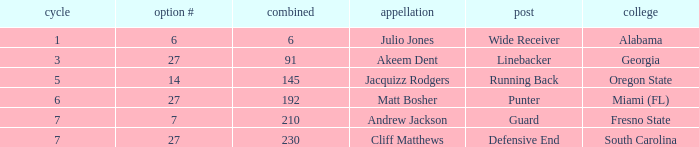Would you be able to parse every entry in this table? {'header': ['cycle', 'option #', 'combined', 'appellation', 'post', 'college'], 'rows': [['1', '6', '6', 'Julio Jones', 'Wide Receiver', 'Alabama'], ['3', '27', '91', 'Akeem Dent', 'Linebacker', 'Georgia'], ['5', '14', '145', 'Jacquizz Rodgers', 'Running Back', 'Oregon State'], ['6', '27', '192', 'Matt Bosher', 'Punter', 'Miami (FL)'], ['7', '7', '210', 'Andrew Jackson', 'Guard', 'Fresno State'], ['7', '27', '230', 'Cliff Matthews', 'Defensive End', 'South Carolina']]} What was the maximum draft pick number for akeem dent with an overall under 91? None. 